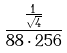Convert formula to latex. <formula><loc_0><loc_0><loc_500><loc_500>\frac { \frac { 1 } { \sqrt { 4 } } } { 8 8 \cdot 2 5 6 }</formula> 